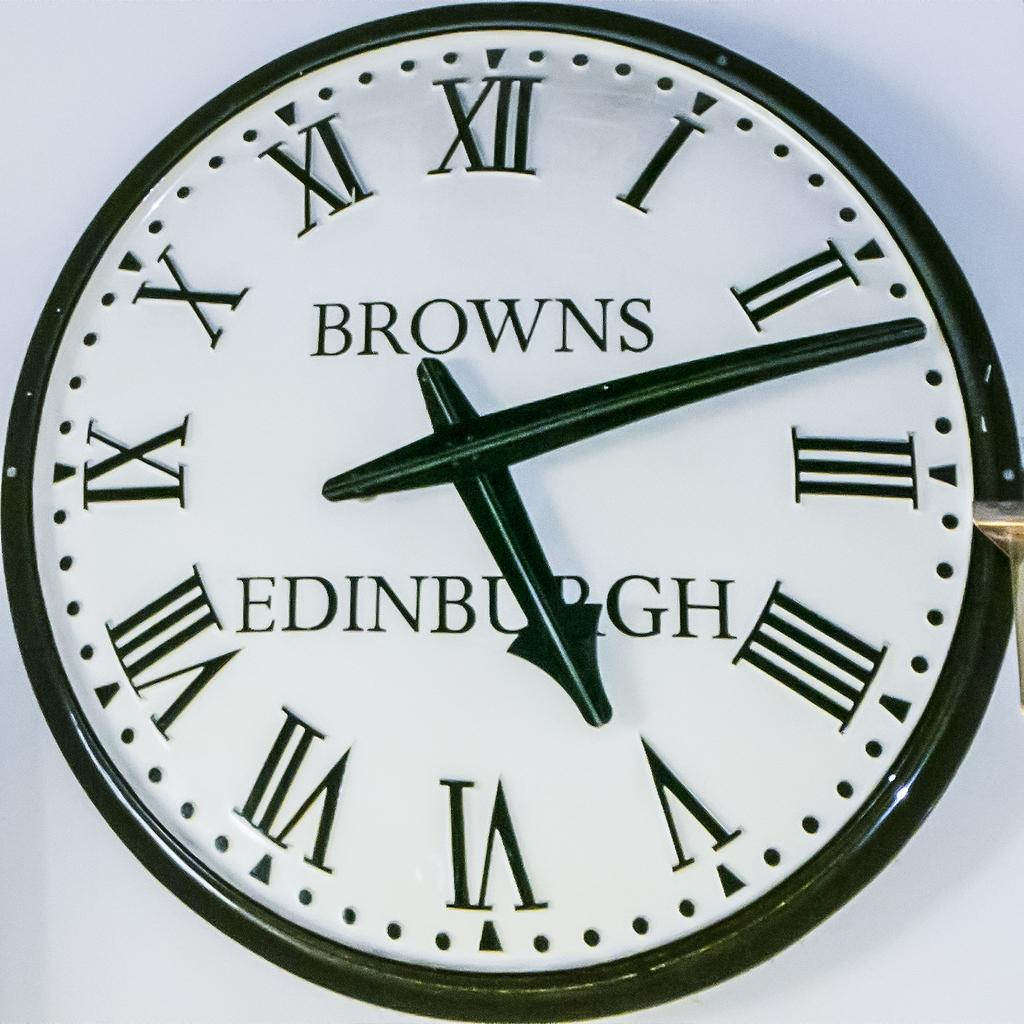<image>
Relay a brief, clear account of the picture shown. A clock with "BROWNS EDINBURGH" on it  reads 5:12. 